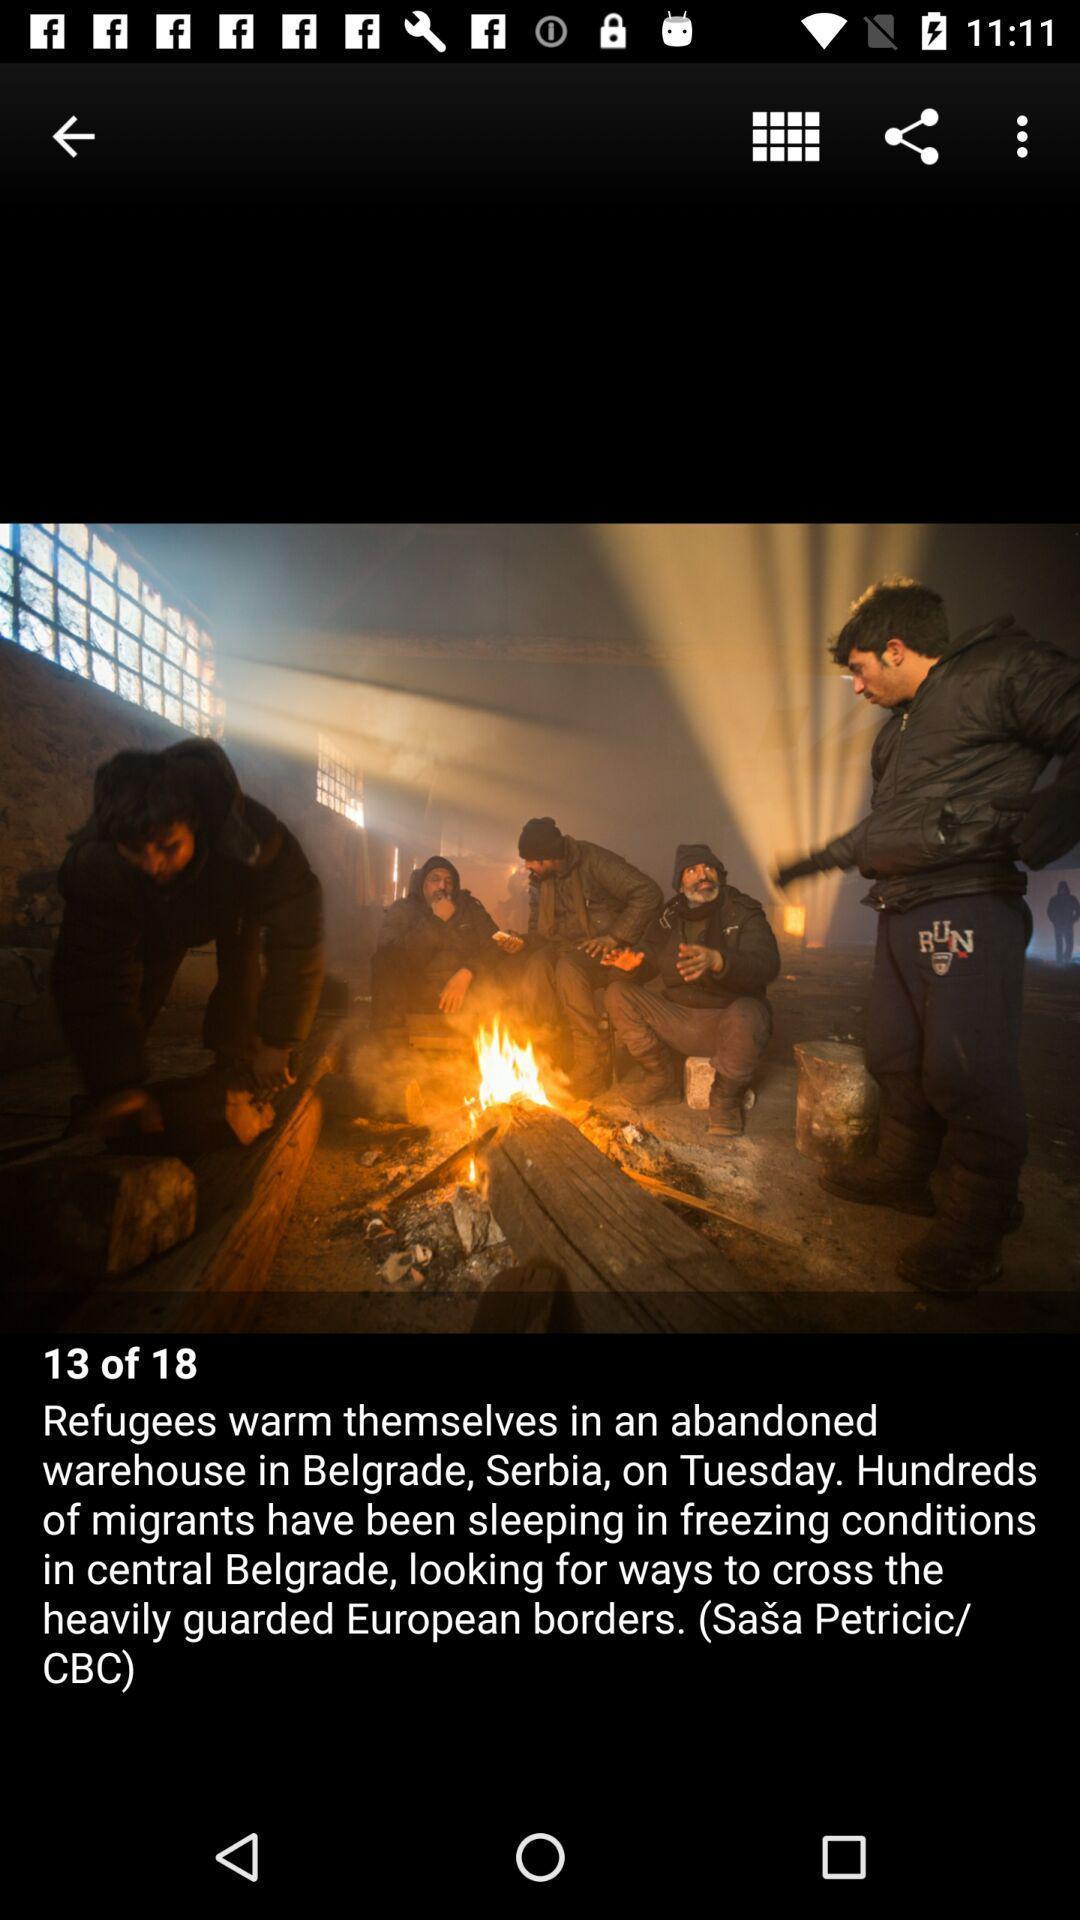Please provide a description for this image. Screen shows about news alerts in the news app. 